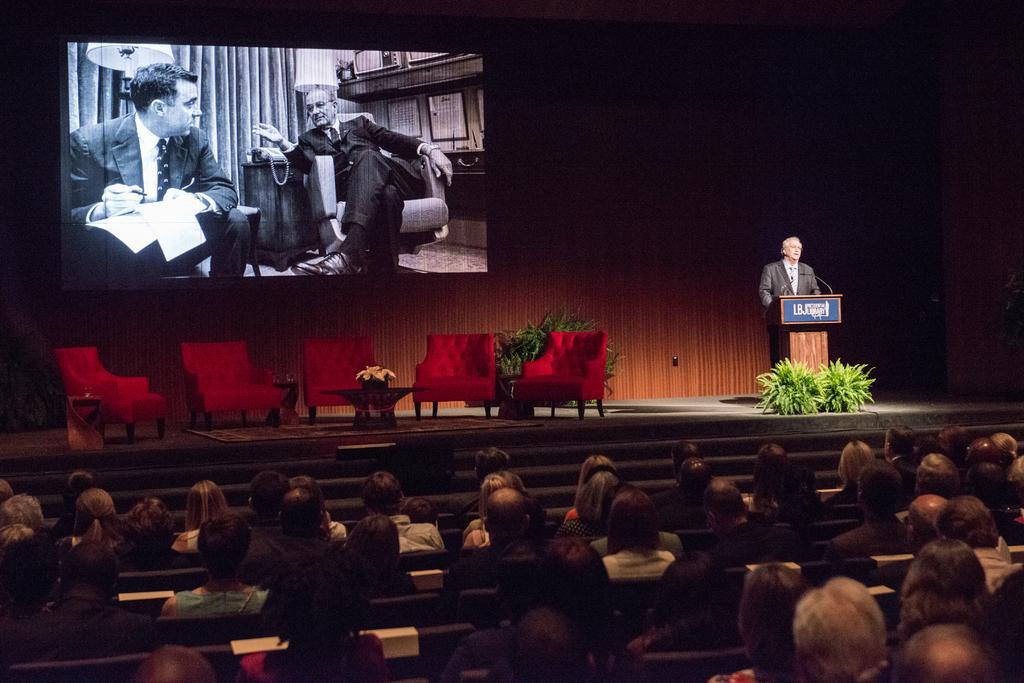Can you describe this image briefly? In this picture I can see some chairs, tables are on the stage, side one person is standing and talking in front of the mike and also there is a display on the board, in front few people are sitting and watching. 